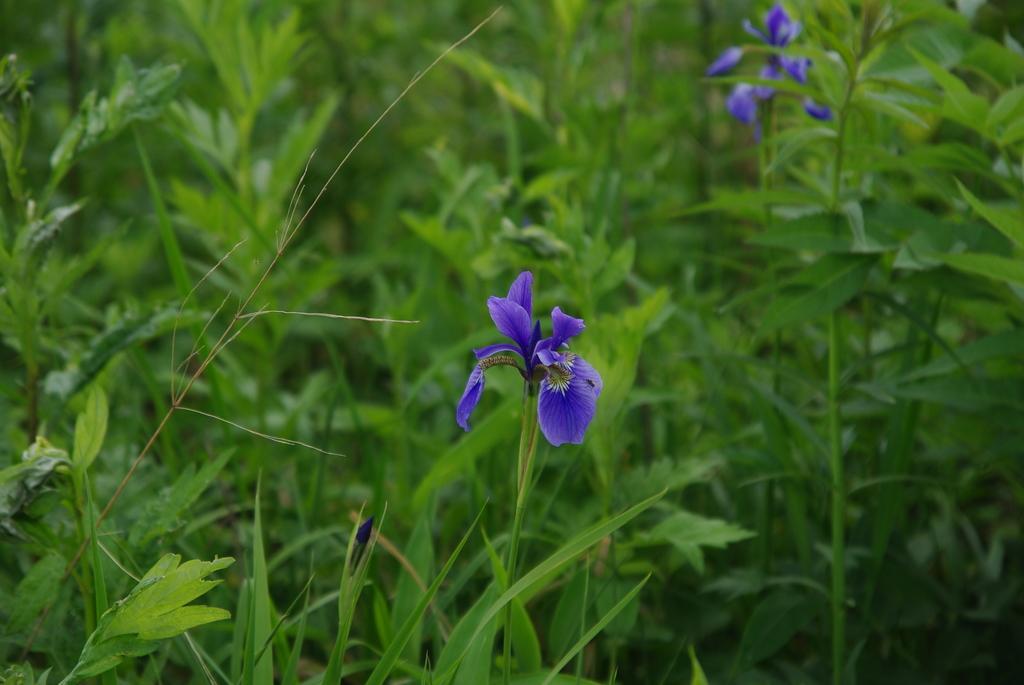Can you describe this image briefly? In this image there are flowers and plants. 